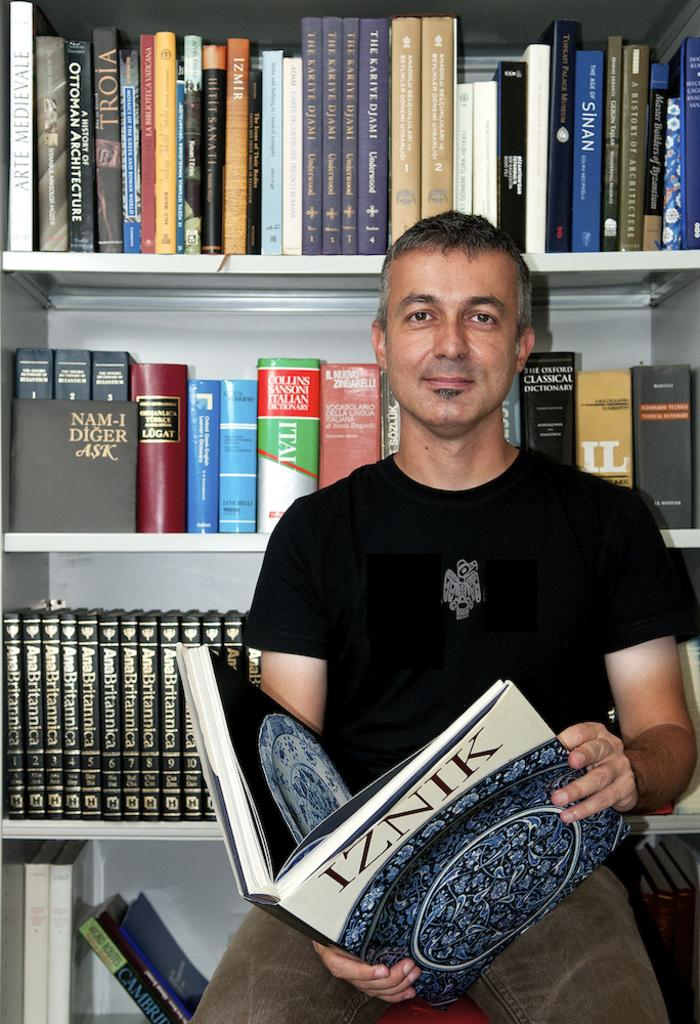Who is present in the image? There is a man in the image. What is the man doing in the image? The man is sitting on a platform and holding a book in his hands. What can be seen in the background of the image? There are books on racks in the background of the image. What is the man doing to his throat in the image? There is no indication in the image that the man is doing anything to his throat. 